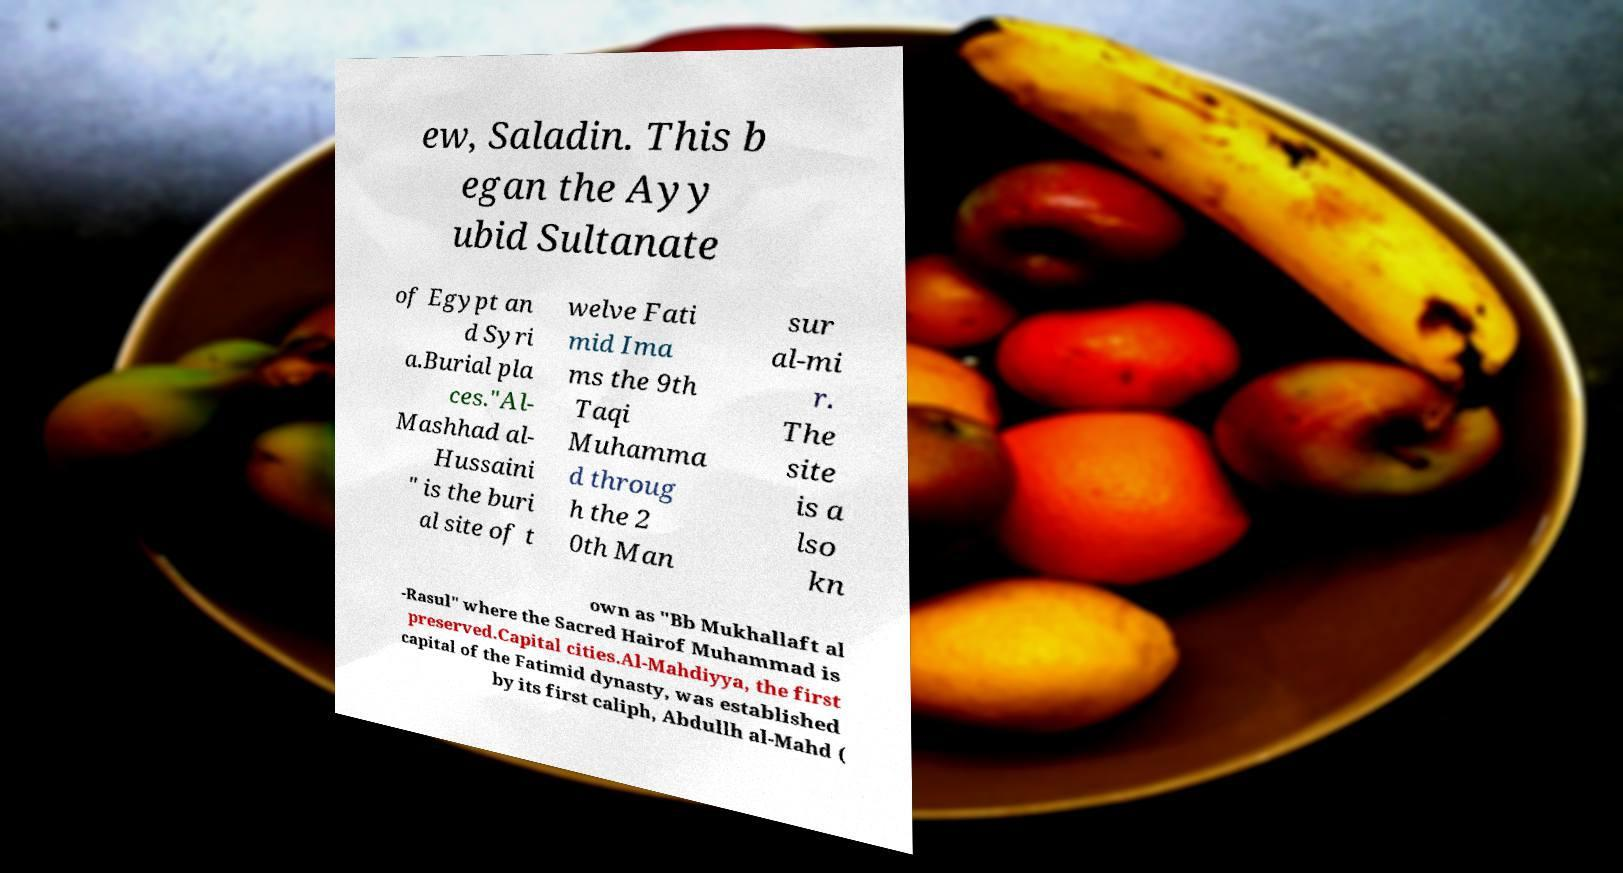Please read and relay the text visible in this image. What does it say? ew, Saladin. This b egan the Ayy ubid Sultanate of Egypt an d Syri a.Burial pla ces."Al- Mashhad al- Hussaini " is the buri al site of t welve Fati mid Ima ms the 9th Taqi Muhamma d throug h the 2 0th Man sur al-mi r. The site is a lso kn own as "Bb Mukhallaft al -Rasul" where the Sacred Hairof Muhammad is preserved.Capital cities.Al-Mahdiyya, the first capital of the Fatimid dynasty, was established by its first caliph, Abdullh al-Mahd ( 